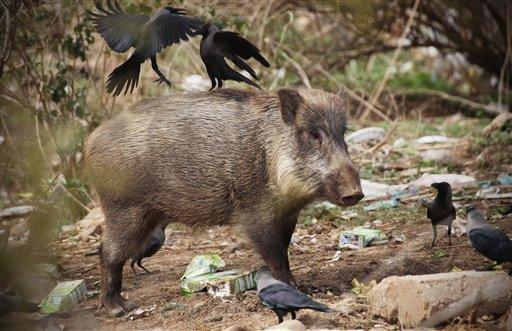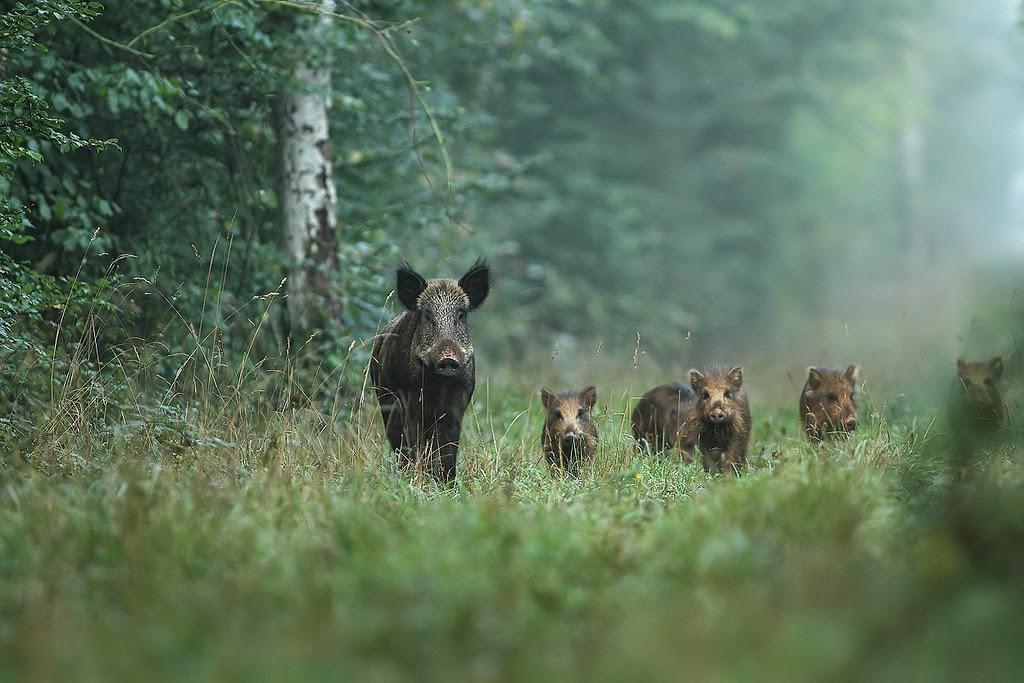The first image is the image on the left, the second image is the image on the right. Analyze the images presented: Is the assertion "One wild pig is standing in the grass in the image on the left." valid? Answer yes or no. No. 